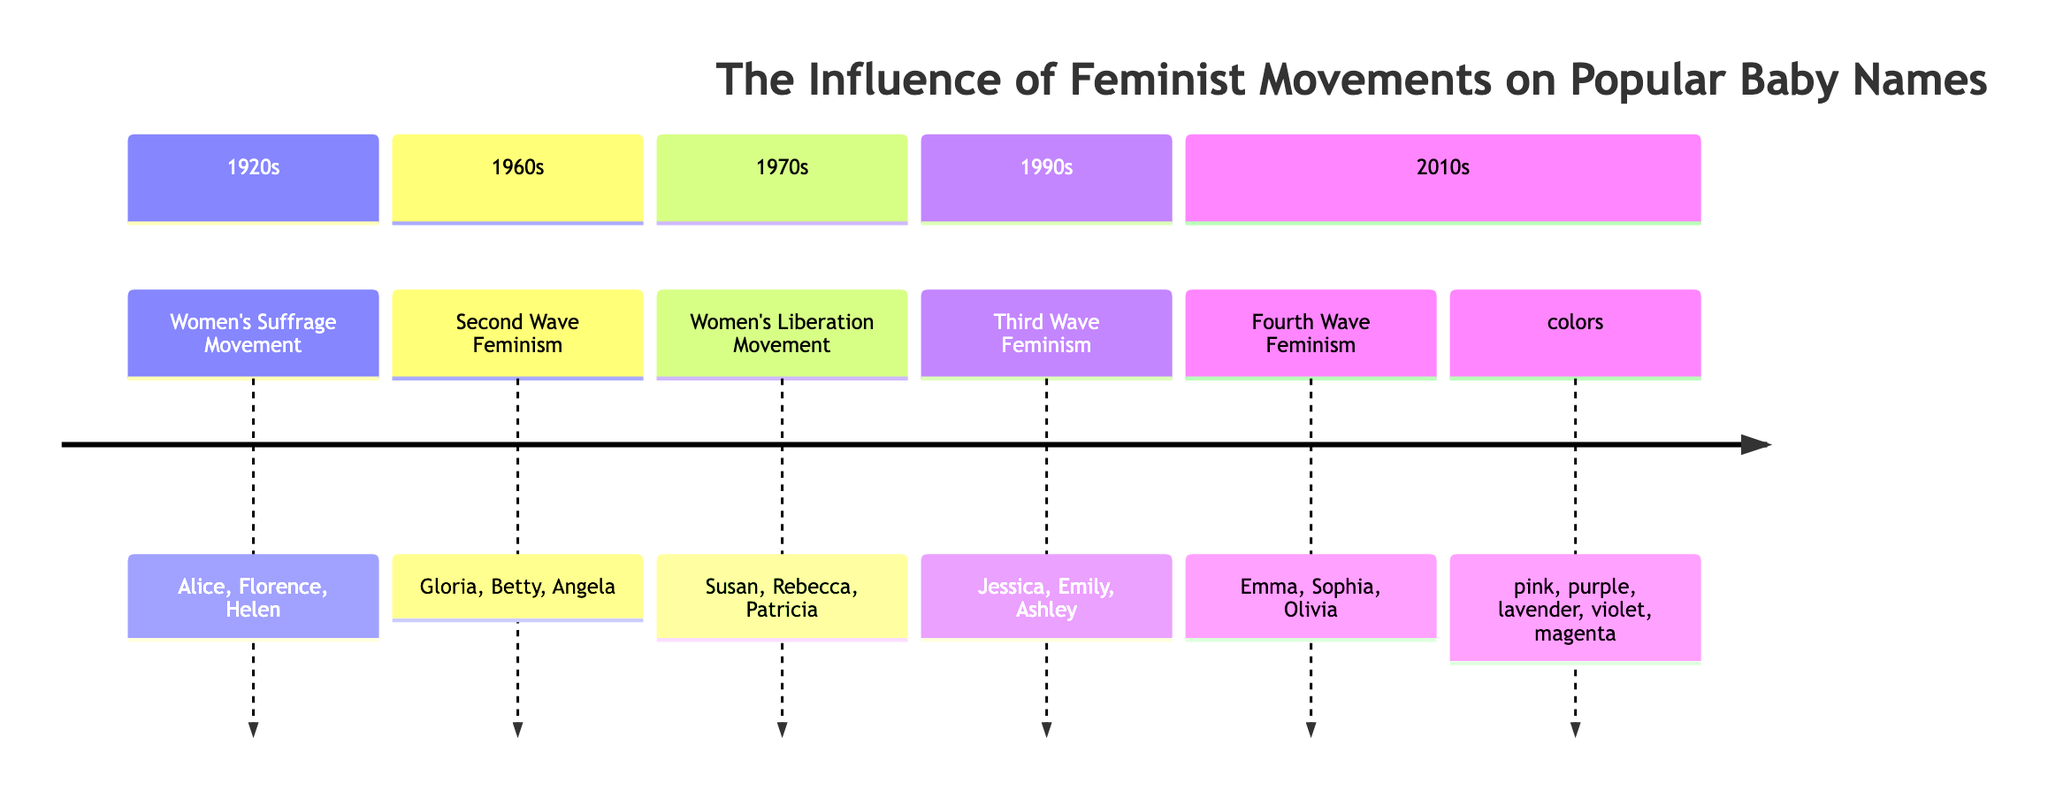What decade is associated with the Women's Suffrage Movement? The Women's Suffrage Movement is specifically associated with the 1920s, which is indicated in the timeline.
Answer: 1920s Which names were popular during the 1960s? According to the timeline, the names that gained popularity in the 1960s due to the Second Wave Feminism were Gloria, Betty, and Angela.
Answer: Gloria, Betty, Angela What feminist movement influenced baby names in the 1970s? The timeline indicates that the Women's Liberation Movement was influential in the 1970s, affecting popular baby names during that decade.
Answer: Women's Liberation Movement How many sections are depicted in the diagram? There are five distinct decades or sections represented in the timeline, showcasing different feminist movements and their impact on baby names.
Answer: 5 Which name was influenced by the Fourth Wave Feminism? The timeline specifies that the name Emma saw a surge in popularity due to Fourth Wave Feminism and the influence of figures like Emma Watson.
Answer: Emma What is the relationship between the 1990s and the focus of feminism during that time? In the 1990s, Third Wave Feminism focused on individuality and diversity, which led to a rise in names like Jessica, Emily, and Ashley, as noted in the historical context.
Answer: Individuality and diversity What colors are used in the timeline? The diagram indicates that the colors pink, purple, lavender, violet, and magenta are used to represent different sections across the timeline.
Answer: pink, purple, lavender, violet, magenta Which name is associated with the 2010s and social media influence? The name Olivia is highlighted in the timeline as being associated with Fourth Wave Feminism and societal changes brought by the rise of social media in the 2010s.
Answer: Olivia What historical context is linked to the names Susan, Rebecca, and Patricia? The historical context provided for the 1970s indicates these names were popular due to the Women's Liberation Movement and influential literature and leaders during that decade.
Answer: Women's Liberation Movement and literature 